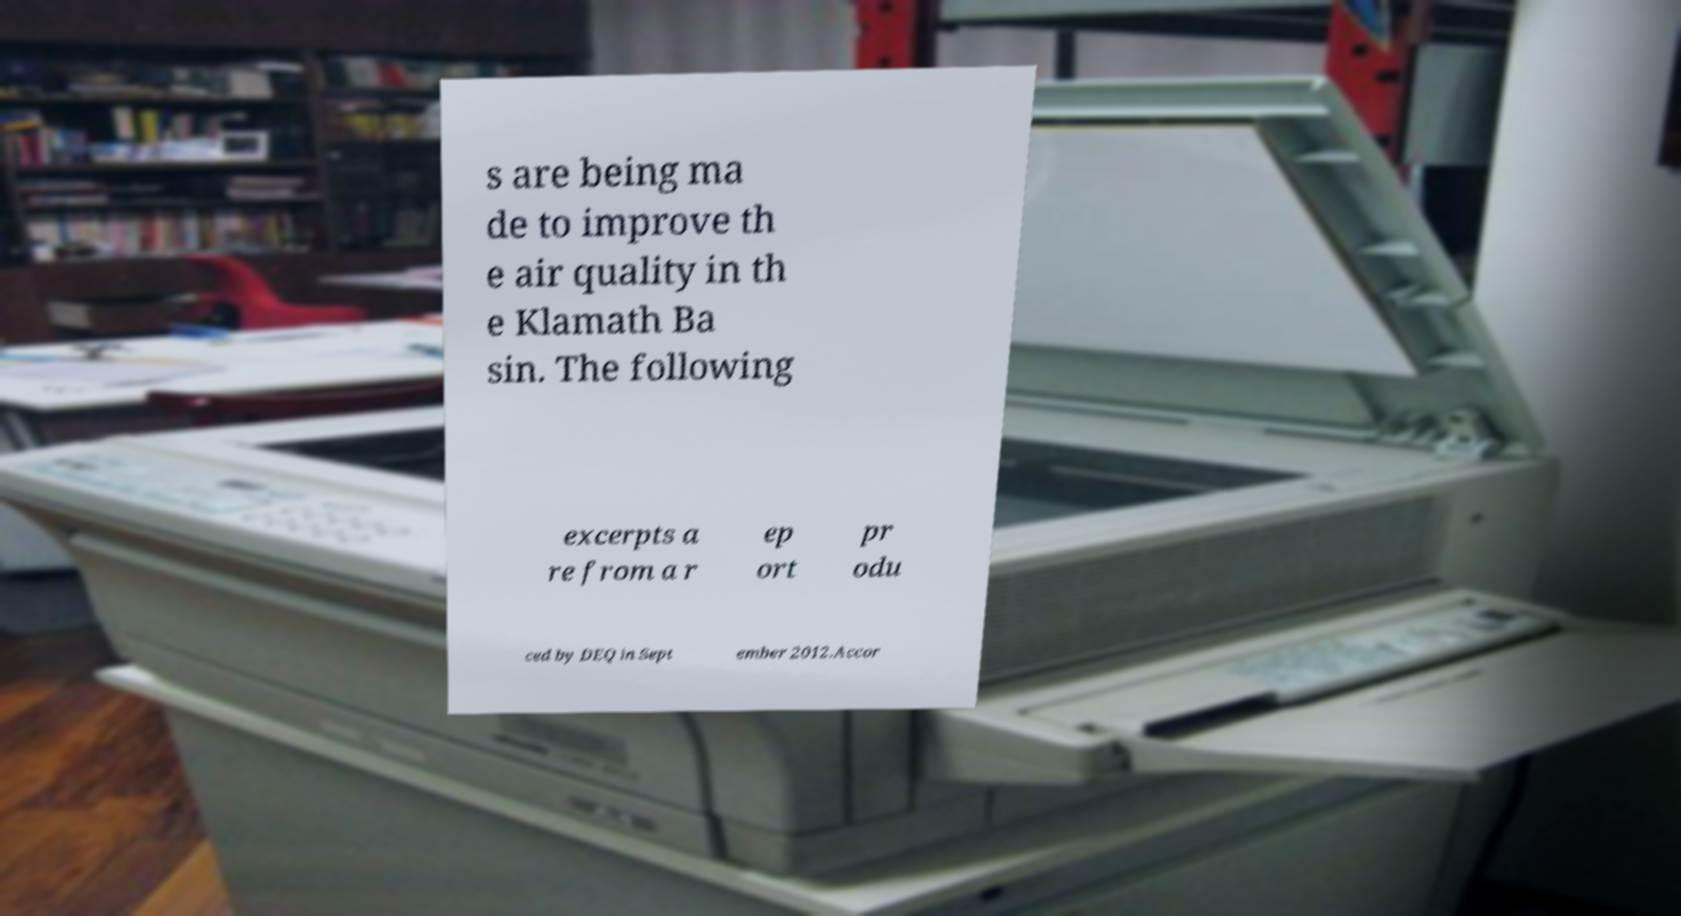There's text embedded in this image that I need extracted. Can you transcribe it verbatim? s are being ma de to improve th e air quality in th e Klamath Ba sin. The following excerpts a re from a r ep ort pr odu ced by DEQ in Sept ember 2012.Accor 